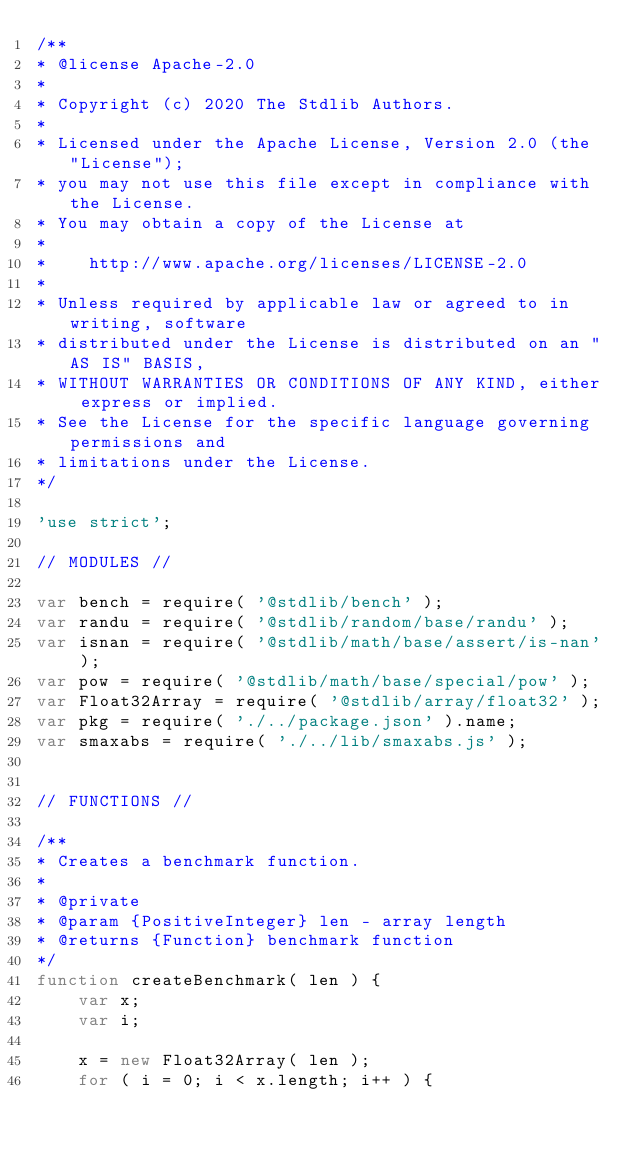<code> <loc_0><loc_0><loc_500><loc_500><_JavaScript_>/**
* @license Apache-2.0
*
* Copyright (c) 2020 The Stdlib Authors.
*
* Licensed under the Apache License, Version 2.0 (the "License");
* you may not use this file except in compliance with the License.
* You may obtain a copy of the License at
*
*    http://www.apache.org/licenses/LICENSE-2.0
*
* Unless required by applicable law or agreed to in writing, software
* distributed under the License is distributed on an "AS IS" BASIS,
* WITHOUT WARRANTIES OR CONDITIONS OF ANY KIND, either express or implied.
* See the License for the specific language governing permissions and
* limitations under the License.
*/

'use strict';

// MODULES //

var bench = require( '@stdlib/bench' );
var randu = require( '@stdlib/random/base/randu' );
var isnan = require( '@stdlib/math/base/assert/is-nan' );
var pow = require( '@stdlib/math/base/special/pow' );
var Float32Array = require( '@stdlib/array/float32' );
var pkg = require( './../package.json' ).name;
var smaxabs = require( './../lib/smaxabs.js' );


// FUNCTIONS //

/**
* Creates a benchmark function.
*
* @private
* @param {PositiveInteger} len - array length
* @returns {Function} benchmark function
*/
function createBenchmark( len ) {
	var x;
	var i;

	x = new Float32Array( len );
	for ( i = 0; i < x.length; i++ ) {</code> 